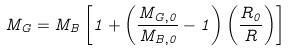Convert formula to latex. <formula><loc_0><loc_0><loc_500><loc_500>M _ { G } = M _ { B } \left [ 1 + \left ( \frac { M _ { G , 0 } } { M _ { B , 0 } } - 1 \right ) \left ( \frac { R _ { 0 } } { R } \right ) \right ]</formula> 